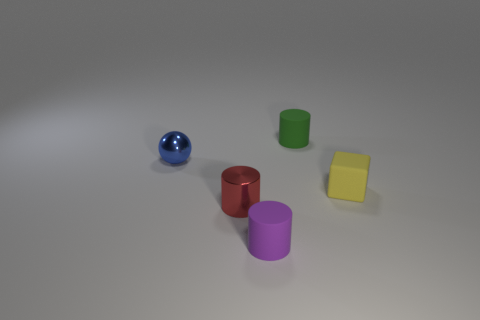Is there anything else that has the same shape as the tiny yellow thing?
Your answer should be compact. No. Are there any yellow cubes that have the same material as the tiny red object?
Offer a terse response. No. What color is the small metallic thing that is to the right of the small metal sphere?
Provide a succinct answer. Red. There is a tiny purple rubber thing; is its shape the same as the matte object on the right side of the green cylinder?
Ensure brevity in your answer.  No. Does the ball have the same color as the cube?
Keep it short and to the point. No. Does the metal thing that is right of the small ball have the same shape as the small purple thing?
Keep it short and to the point. Yes. What number of yellow matte cubes have the same size as the yellow matte object?
Give a very brief answer. 0. Are there any tiny matte cylinders in front of the tiny green cylinder that is behind the red cylinder?
Ensure brevity in your answer.  Yes. How many things are either matte things behind the tiny red metallic cylinder or cyan metallic things?
Provide a short and direct response. 2. How many tiny red rubber blocks are there?
Your response must be concise. 0. 